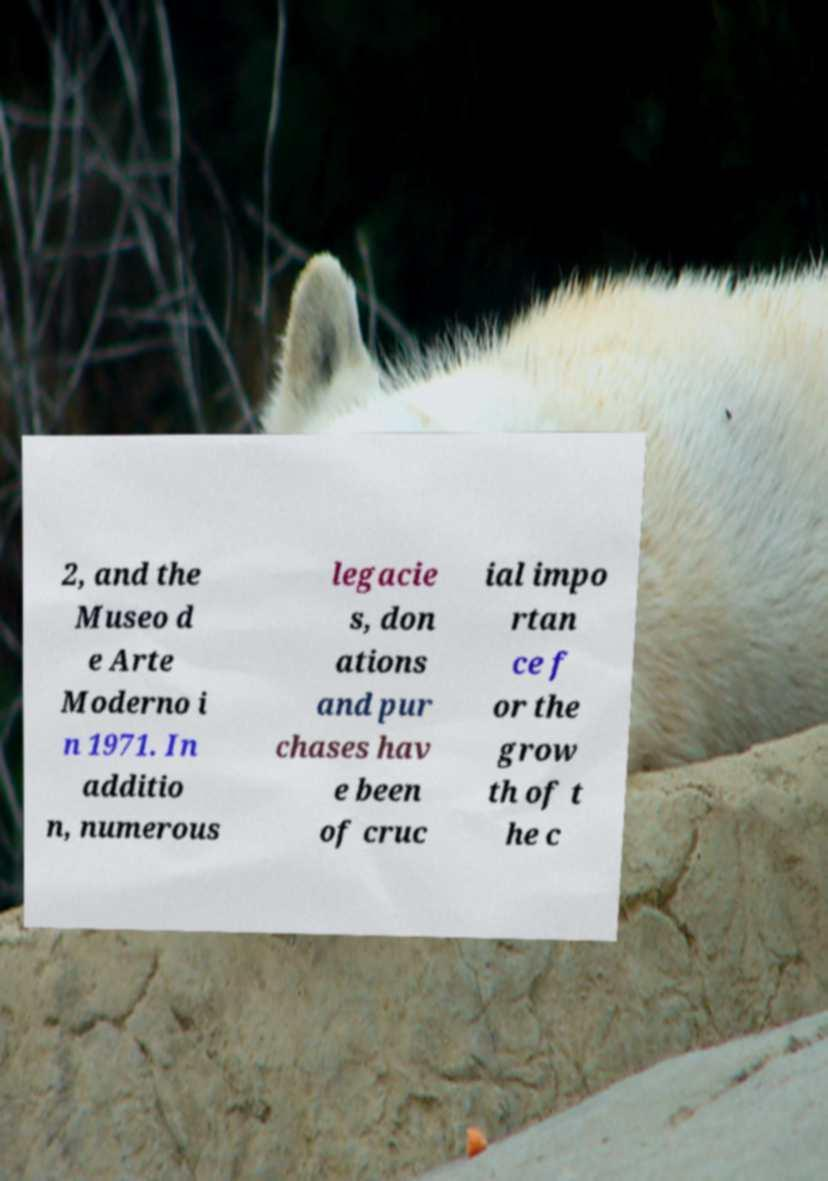Please read and relay the text visible in this image. What does it say? 2, and the Museo d e Arte Moderno i n 1971. In additio n, numerous legacie s, don ations and pur chases hav e been of cruc ial impo rtan ce f or the grow th of t he c 